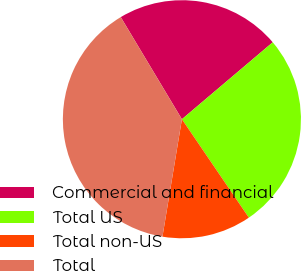Convert chart. <chart><loc_0><loc_0><loc_500><loc_500><pie_chart><fcel>Commercial and financial<fcel>Total US<fcel>Total non-US<fcel>Total<nl><fcel>22.4%<fcel>26.68%<fcel>12.12%<fcel>38.8%<nl></chart> 